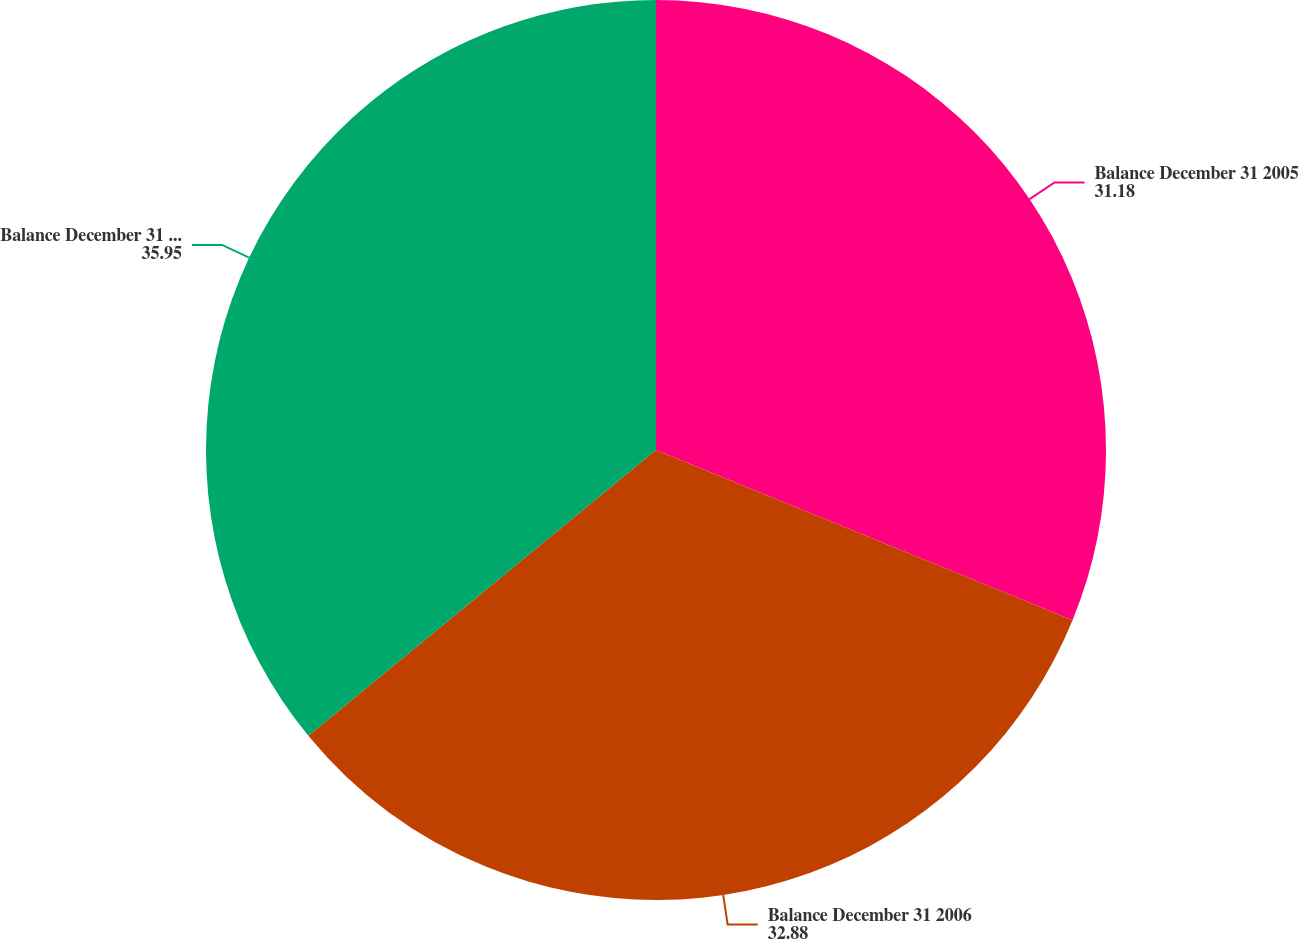Convert chart to OTSL. <chart><loc_0><loc_0><loc_500><loc_500><pie_chart><fcel>Balance December 31 2005<fcel>Balance December 31 2006<fcel>Balance December 31 2007<nl><fcel>31.18%<fcel>32.88%<fcel>35.95%<nl></chart> 